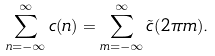Convert formula to latex. <formula><loc_0><loc_0><loc_500><loc_500>\sum _ { n = - \infty } ^ { \infty } c ( n ) = \sum _ { m = - \infty } ^ { \infty } \tilde { c } ( 2 \pi m ) .</formula> 